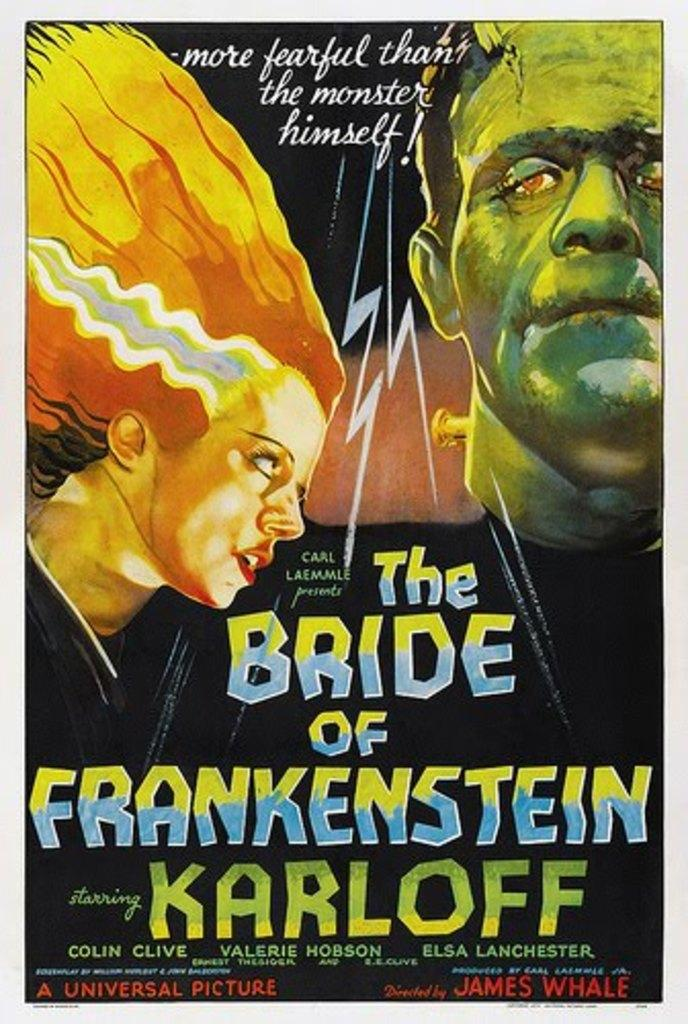<image>
Create a compact narrative representing the image presented. A book by Karloff has a picture of the bride of Frankenstein on the cover. n 